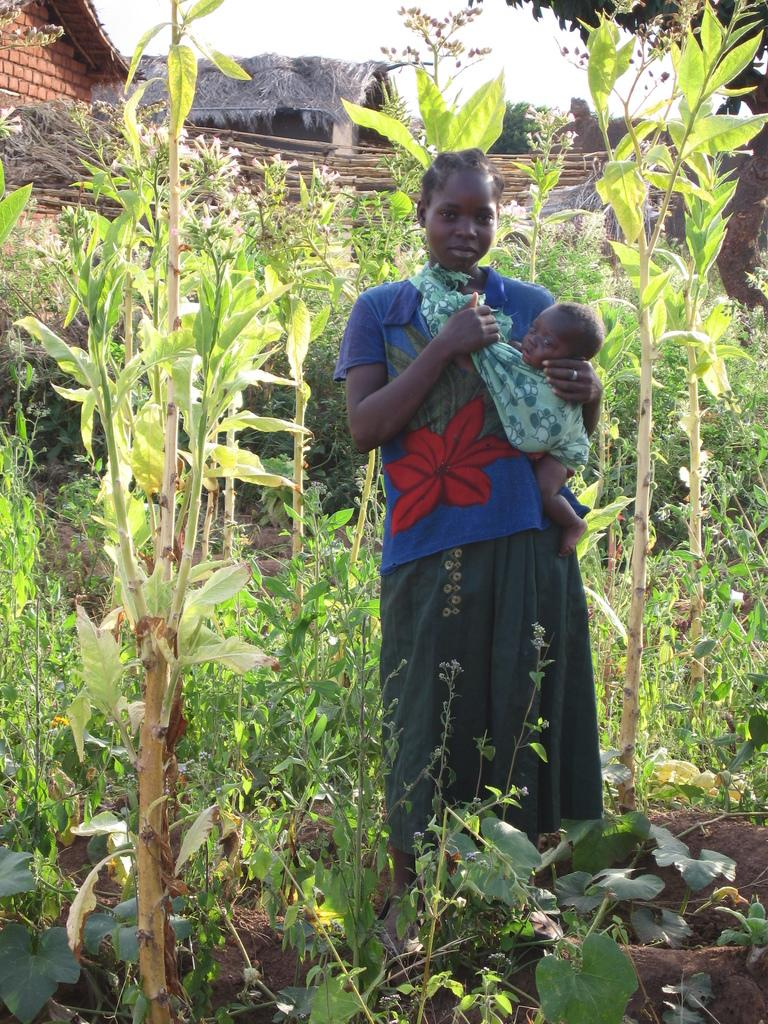Who is the main subject in the image? There is a woman in the image. What is the woman doing in the image? The woman is holding a baby. What is the setting of the image? The woman is standing among plants and trees. What can be seen in the background of the image? There is a house and the sky visible in the background of the image. What type of force is being applied to the ring in the image? There is no ring present in the image, so no force can be applied to it. 